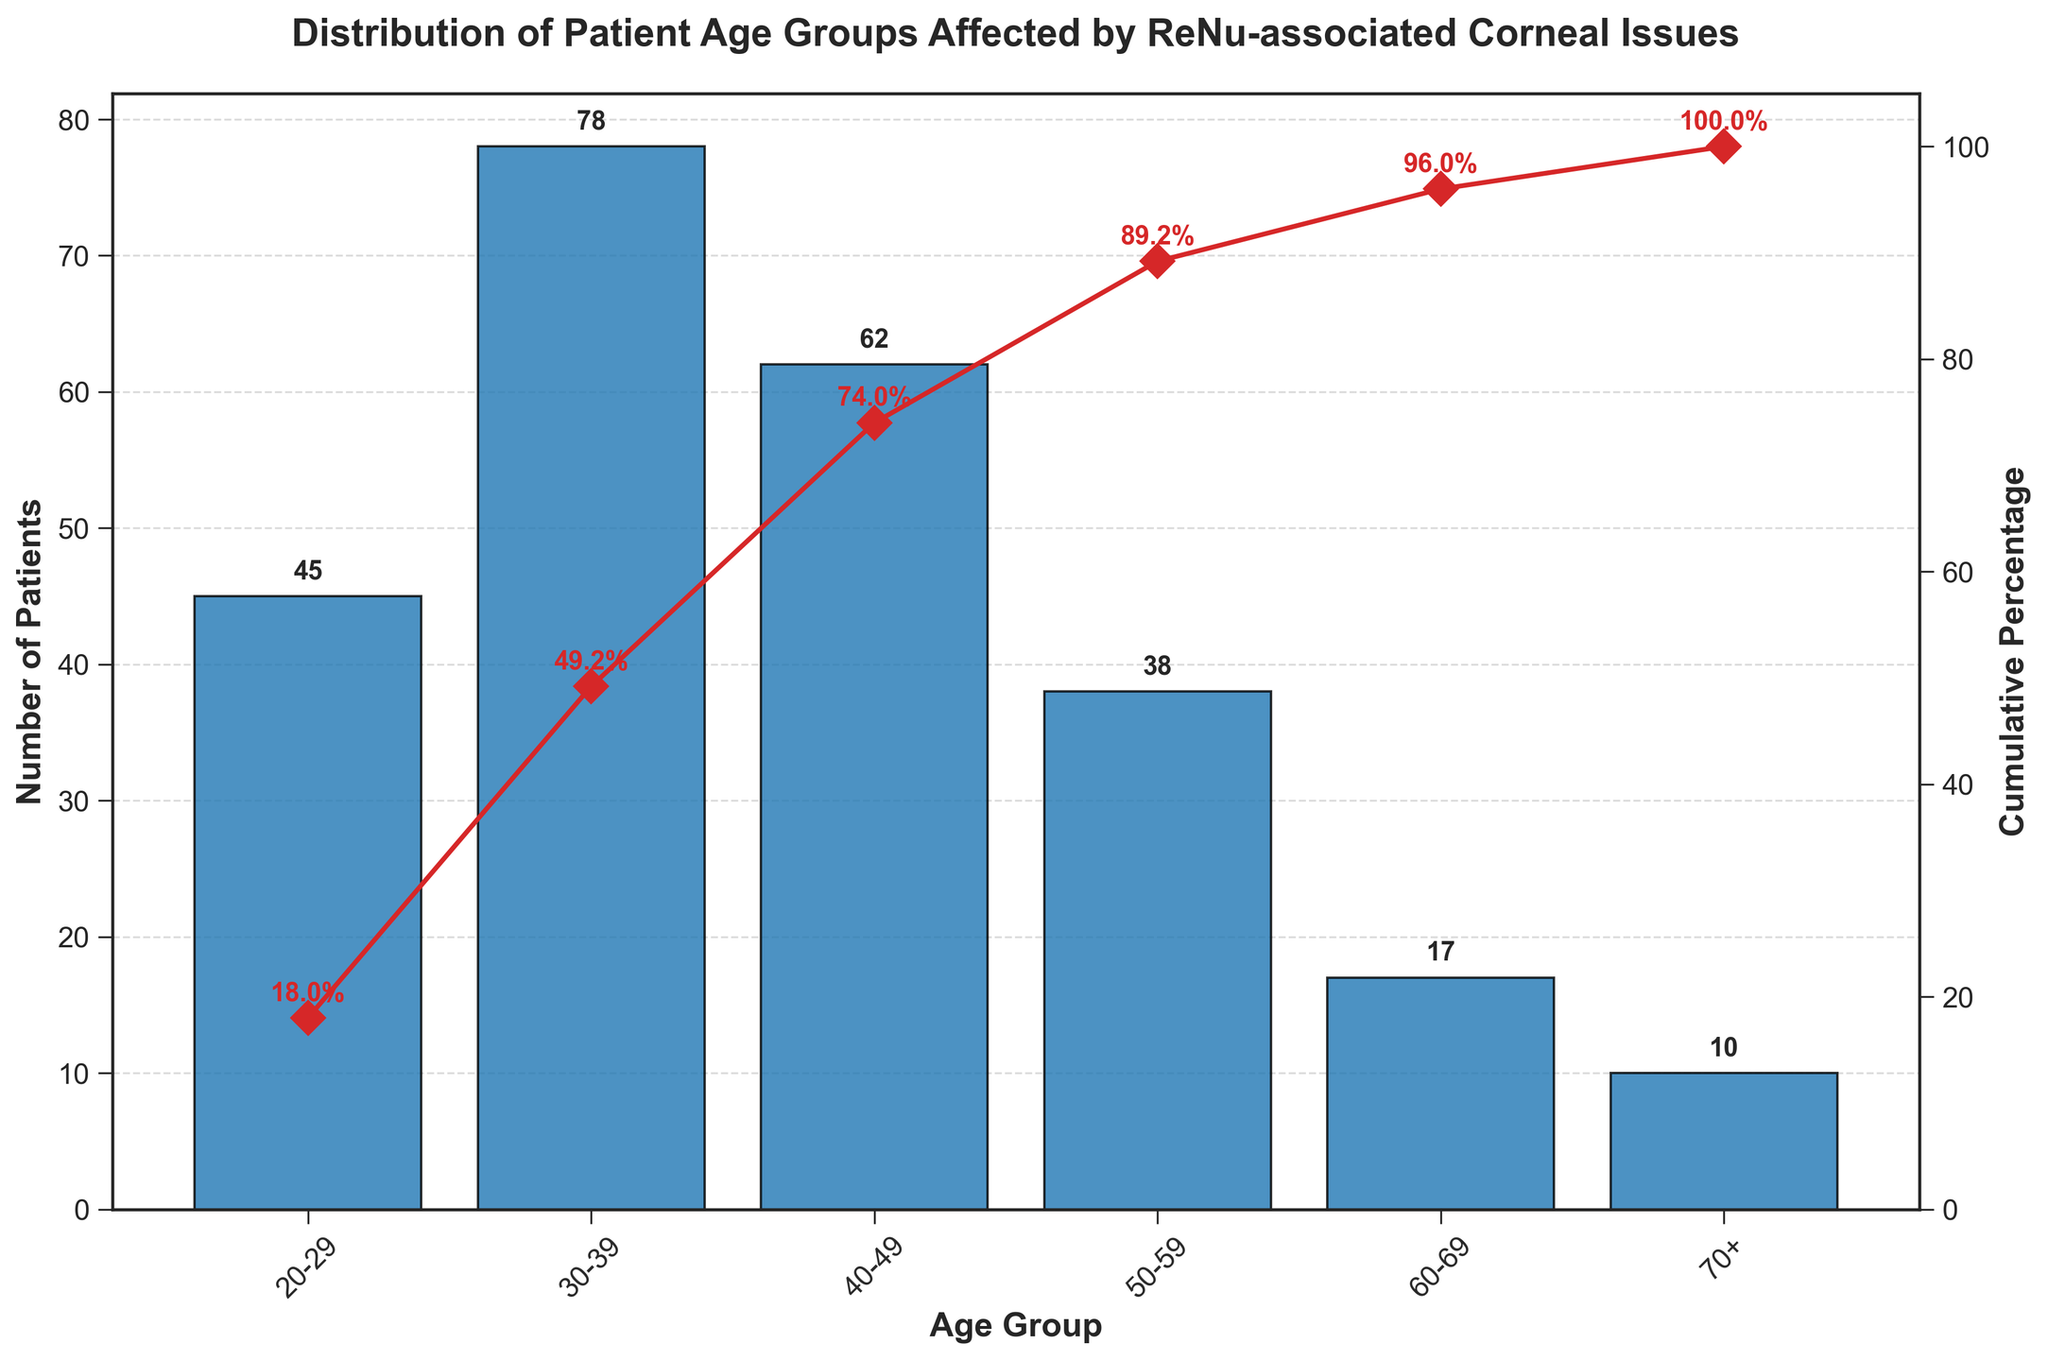What is the age group with the highest number of patients? By observing the bar heights, the highest bar corresponds to the 30-39 age group. This age group has the largest number of patients.
Answer: 30-39 What is the cumulative percentage for the age group 50-59? Find the cumulative percentage value associated with the 50-59 age group along the right y-axis.
Answer: 89.2% How many total age groups are shown in the figure? Count the number of distinct age groups along the x-axis.
Answer: 6 Which age group has the lowest cumulative percentage? The lowest cumulative percentage value marks the 20-29 age group.
Answer: 20-29 How does the number of patients in the 40-49 age group compare to the 50-59 age group? Identify the height of the bars for both age groups and compare their values. The 40-49 age group has 62 patients, while the 50-59 age group has 38 patients.
Answer: 40-49 has more What is the cumulative percentage difference between the 30-39 and 40-49 age groups? Subtract the cumulative percentage of 30-39 (49.2%) from that of 40-49 (74.0%). The difference is 74.0% - 49.2%.
Answer: 24.8% Which two age groups combined account for approximately half of the patients? Sum the percentage values for different combinations of age groups to see which add up to around 50%. The 20-29 and 30-39 age groups together account for 18.0% + 31.2% = 49.2%.
Answer: 20-29 and 30-39 What is the cumulative percentage after including the 40-49 age group? By checking the figure, the cumulative percentage after including the 40-49 age group is visible.
Answer: 74.0% What percentage of patients are aged 50 and above? Sum the number of patients in the age groups 50-59 (38), 60-69 (17), and 70+ (10). Calculate the cumulative percentage from the total number of patients. 38 + 17 + 10 = 65 out of 250 total patients.
Answer: 26.0% Do the age groups follow a trend in terms of the number of patients, increasing or decreasing with age? Observing the bar heights from youngest to oldest, there's an increasing trend up to the 30-39 age group, then a decreasing trend in successive age groups.
Answer: Increasing then decreasing 